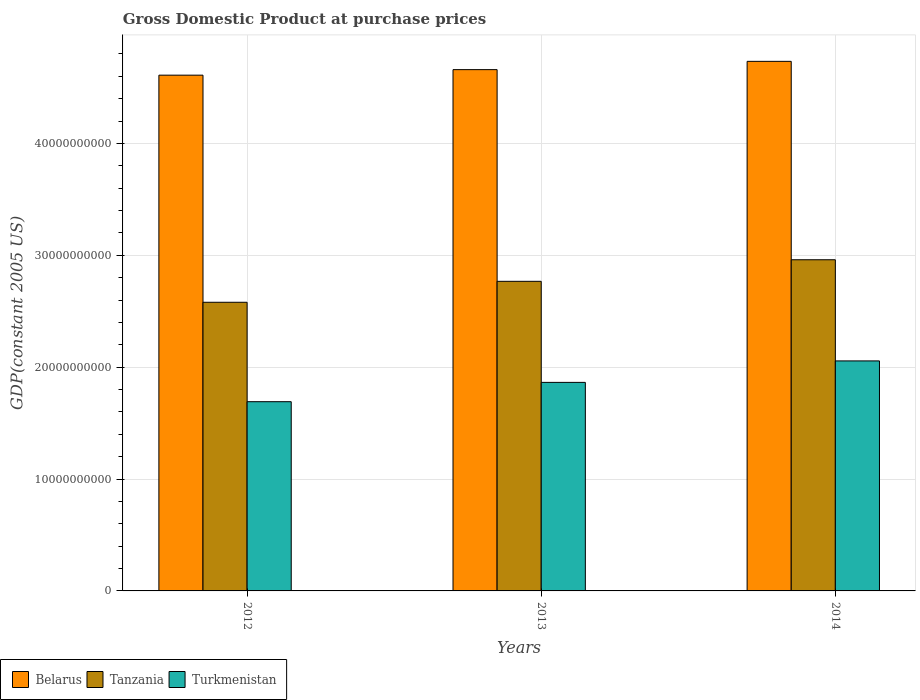How many different coloured bars are there?
Your answer should be very brief. 3. Are the number of bars on each tick of the X-axis equal?
Provide a succinct answer. Yes. How many bars are there on the 1st tick from the right?
Provide a succinct answer. 3. What is the label of the 3rd group of bars from the left?
Make the answer very short. 2014. What is the GDP at purchase prices in Tanzania in 2014?
Provide a short and direct response. 2.96e+1. Across all years, what is the maximum GDP at purchase prices in Belarus?
Provide a succinct answer. 4.73e+1. Across all years, what is the minimum GDP at purchase prices in Belarus?
Offer a terse response. 4.61e+1. In which year was the GDP at purchase prices in Tanzania maximum?
Your answer should be compact. 2014. In which year was the GDP at purchase prices in Turkmenistan minimum?
Offer a terse response. 2012. What is the total GDP at purchase prices in Belarus in the graph?
Provide a succinct answer. 1.40e+11. What is the difference between the GDP at purchase prices in Belarus in 2012 and that in 2014?
Give a very brief answer. -1.23e+09. What is the difference between the GDP at purchase prices in Belarus in 2012 and the GDP at purchase prices in Turkmenistan in 2013?
Provide a short and direct response. 2.75e+1. What is the average GDP at purchase prices in Turkmenistan per year?
Offer a terse response. 1.87e+1. In the year 2013, what is the difference between the GDP at purchase prices in Tanzania and GDP at purchase prices in Turkmenistan?
Your answer should be compact. 9.03e+09. What is the ratio of the GDP at purchase prices in Tanzania in 2012 to that in 2014?
Make the answer very short. 0.87. Is the GDP at purchase prices in Belarus in 2012 less than that in 2013?
Offer a very short reply. Yes. What is the difference between the highest and the second highest GDP at purchase prices in Turkmenistan?
Your response must be concise. 1.92e+09. What is the difference between the highest and the lowest GDP at purchase prices in Turkmenistan?
Offer a very short reply. 3.65e+09. In how many years, is the GDP at purchase prices in Belarus greater than the average GDP at purchase prices in Belarus taken over all years?
Provide a short and direct response. 1. Is the sum of the GDP at purchase prices in Turkmenistan in 2012 and 2014 greater than the maximum GDP at purchase prices in Tanzania across all years?
Give a very brief answer. Yes. What does the 2nd bar from the left in 2013 represents?
Offer a very short reply. Tanzania. What does the 3rd bar from the right in 2014 represents?
Provide a succinct answer. Belarus. How many bars are there?
Provide a short and direct response. 9. What is the difference between two consecutive major ticks on the Y-axis?
Provide a succinct answer. 1.00e+1. Does the graph contain any zero values?
Give a very brief answer. No. Where does the legend appear in the graph?
Provide a short and direct response. Bottom left. How are the legend labels stacked?
Your answer should be very brief. Horizontal. What is the title of the graph?
Your answer should be compact. Gross Domestic Product at purchase prices. What is the label or title of the X-axis?
Offer a terse response. Years. What is the label or title of the Y-axis?
Provide a short and direct response. GDP(constant 2005 US). What is the GDP(constant 2005 US) in Belarus in 2012?
Your response must be concise. 4.61e+1. What is the GDP(constant 2005 US) in Tanzania in 2012?
Keep it short and to the point. 2.58e+1. What is the GDP(constant 2005 US) of Turkmenistan in 2012?
Ensure brevity in your answer.  1.69e+1. What is the GDP(constant 2005 US) in Belarus in 2013?
Give a very brief answer. 4.66e+1. What is the GDP(constant 2005 US) in Tanzania in 2013?
Ensure brevity in your answer.  2.77e+1. What is the GDP(constant 2005 US) in Turkmenistan in 2013?
Make the answer very short. 1.86e+1. What is the GDP(constant 2005 US) of Belarus in 2014?
Make the answer very short. 4.73e+1. What is the GDP(constant 2005 US) in Tanzania in 2014?
Make the answer very short. 2.96e+1. What is the GDP(constant 2005 US) in Turkmenistan in 2014?
Ensure brevity in your answer.  2.06e+1. Across all years, what is the maximum GDP(constant 2005 US) of Belarus?
Keep it short and to the point. 4.73e+1. Across all years, what is the maximum GDP(constant 2005 US) in Tanzania?
Provide a short and direct response. 2.96e+1. Across all years, what is the maximum GDP(constant 2005 US) in Turkmenistan?
Keep it short and to the point. 2.06e+1. Across all years, what is the minimum GDP(constant 2005 US) in Belarus?
Ensure brevity in your answer.  4.61e+1. Across all years, what is the minimum GDP(constant 2005 US) in Tanzania?
Provide a short and direct response. 2.58e+1. Across all years, what is the minimum GDP(constant 2005 US) in Turkmenistan?
Your answer should be very brief. 1.69e+1. What is the total GDP(constant 2005 US) in Belarus in the graph?
Ensure brevity in your answer.  1.40e+11. What is the total GDP(constant 2005 US) in Tanzania in the graph?
Provide a succinct answer. 8.31e+1. What is the total GDP(constant 2005 US) of Turkmenistan in the graph?
Your response must be concise. 5.61e+1. What is the difference between the GDP(constant 2005 US) of Belarus in 2012 and that in 2013?
Provide a succinct answer. -4.95e+08. What is the difference between the GDP(constant 2005 US) in Tanzania in 2012 and that in 2013?
Give a very brief answer. -1.87e+09. What is the difference between the GDP(constant 2005 US) in Turkmenistan in 2012 and that in 2013?
Your answer should be very brief. -1.73e+09. What is the difference between the GDP(constant 2005 US) of Belarus in 2012 and that in 2014?
Offer a terse response. -1.23e+09. What is the difference between the GDP(constant 2005 US) in Tanzania in 2012 and that in 2014?
Offer a terse response. -3.80e+09. What is the difference between the GDP(constant 2005 US) of Turkmenistan in 2012 and that in 2014?
Provide a succinct answer. -3.65e+09. What is the difference between the GDP(constant 2005 US) in Belarus in 2013 and that in 2014?
Your answer should be very brief. -7.40e+08. What is the difference between the GDP(constant 2005 US) of Tanzania in 2013 and that in 2014?
Provide a short and direct response. -1.93e+09. What is the difference between the GDP(constant 2005 US) in Turkmenistan in 2013 and that in 2014?
Your answer should be compact. -1.92e+09. What is the difference between the GDP(constant 2005 US) in Belarus in 2012 and the GDP(constant 2005 US) in Tanzania in 2013?
Offer a very short reply. 1.84e+1. What is the difference between the GDP(constant 2005 US) in Belarus in 2012 and the GDP(constant 2005 US) in Turkmenistan in 2013?
Offer a terse response. 2.75e+1. What is the difference between the GDP(constant 2005 US) of Tanzania in 2012 and the GDP(constant 2005 US) of Turkmenistan in 2013?
Offer a very short reply. 7.16e+09. What is the difference between the GDP(constant 2005 US) in Belarus in 2012 and the GDP(constant 2005 US) in Tanzania in 2014?
Ensure brevity in your answer.  1.65e+1. What is the difference between the GDP(constant 2005 US) of Belarus in 2012 and the GDP(constant 2005 US) of Turkmenistan in 2014?
Make the answer very short. 2.55e+1. What is the difference between the GDP(constant 2005 US) of Tanzania in 2012 and the GDP(constant 2005 US) of Turkmenistan in 2014?
Your answer should be very brief. 5.24e+09. What is the difference between the GDP(constant 2005 US) of Belarus in 2013 and the GDP(constant 2005 US) of Tanzania in 2014?
Keep it short and to the point. 1.70e+1. What is the difference between the GDP(constant 2005 US) of Belarus in 2013 and the GDP(constant 2005 US) of Turkmenistan in 2014?
Provide a succinct answer. 2.60e+1. What is the difference between the GDP(constant 2005 US) in Tanzania in 2013 and the GDP(constant 2005 US) in Turkmenistan in 2014?
Offer a terse response. 7.11e+09. What is the average GDP(constant 2005 US) in Belarus per year?
Your answer should be compact. 4.67e+1. What is the average GDP(constant 2005 US) in Tanzania per year?
Offer a terse response. 2.77e+1. What is the average GDP(constant 2005 US) in Turkmenistan per year?
Ensure brevity in your answer.  1.87e+1. In the year 2012, what is the difference between the GDP(constant 2005 US) of Belarus and GDP(constant 2005 US) of Tanzania?
Give a very brief answer. 2.03e+1. In the year 2012, what is the difference between the GDP(constant 2005 US) of Belarus and GDP(constant 2005 US) of Turkmenistan?
Your answer should be compact. 2.92e+1. In the year 2012, what is the difference between the GDP(constant 2005 US) of Tanzania and GDP(constant 2005 US) of Turkmenistan?
Your answer should be compact. 8.89e+09. In the year 2013, what is the difference between the GDP(constant 2005 US) in Belarus and GDP(constant 2005 US) in Tanzania?
Give a very brief answer. 1.89e+1. In the year 2013, what is the difference between the GDP(constant 2005 US) of Belarus and GDP(constant 2005 US) of Turkmenistan?
Your answer should be very brief. 2.80e+1. In the year 2013, what is the difference between the GDP(constant 2005 US) in Tanzania and GDP(constant 2005 US) in Turkmenistan?
Offer a very short reply. 9.03e+09. In the year 2014, what is the difference between the GDP(constant 2005 US) in Belarus and GDP(constant 2005 US) in Tanzania?
Provide a short and direct response. 1.77e+1. In the year 2014, what is the difference between the GDP(constant 2005 US) in Belarus and GDP(constant 2005 US) in Turkmenistan?
Make the answer very short. 2.68e+1. In the year 2014, what is the difference between the GDP(constant 2005 US) in Tanzania and GDP(constant 2005 US) in Turkmenistan?
Your answer should be compact. 9.04e+09. What is the ratio of the GDP(constant 2005 US) in Belarus in 2012 to that in 2013?
Make the answer very short. 0.99. What is the ratio of the GDP(constant 2005 US) of Tanzania in 2012 to that in 2013?
Provide a succinct answer. 0.93. What is the ratio of the GDP(constant 2005 US) in Turkmenistan in 2012 to that in 2013?
Give a very brief answer. 0.91. What is the ratio of the GDP(constant 2005 US) of Belarus in 2012 to that in 2014?
Provide a short and direct response. 0.97. What is the ratio of the GDP(constant 2005 US) in Tanzania in 2012 to that in 2014?
Ensure brevity in your answer.  0.87. What is the ratio of the GDP(constant 2005 US) in Turkmenistan in 2012 to that in 2014?
Ensure brevity in your answer.  0.82. What is the ratio of the GDP(constant 2005 US) of Belarus in 2013 to that in 2014?
Offer a very short reply. 0.98. What is the ratio of the GDP(constant 2005 US) of Tanzania in 2013 to that in 2014?
Keep it short and to the point. 0.93. What is the ratio of the GDP(constant 2005 US) of Turkmenistan in 2013 to that in 2014?
Provide a succinct answer. 0.91. What is the difference between the highest and the second highest GDP(constant 2005 US) of Belarus?
Give a very brief answer. 7.40e+08. What is the difference between the highest and the second highest GDP(constant 2005 US) in Tanzania?
Give a very brief answer. 1.93e+09. What is the difference between the highest and the second highest GDP(constant 2005 US) of Turkmenistan?
Your answer should be compact. 1.92e+09. What is the difference between the highest and the lowest GDP(constant 2005 US) of Belarus?
Your answer should be compact. 1.23e+09. What is the difference between the highest and the lowest GDP(constant 2005 US) in Tanzania?
Your answer should be compact. 3.80e+09. What is the difference between the highest and the lowest GDP(constant 2005 US) in Turkmenistan?
Offer a terse response. 3.65e+09. 